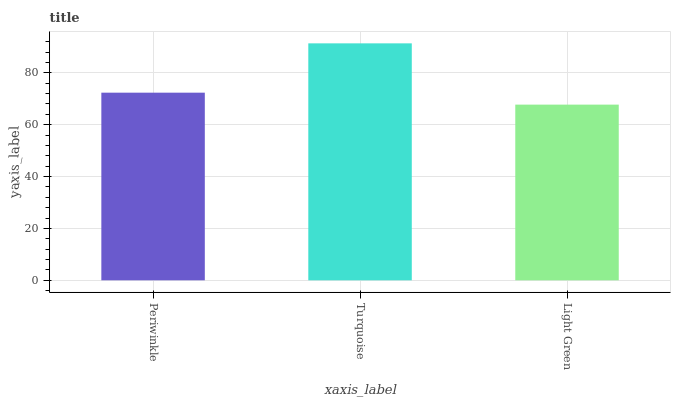Is Light Green the minimum?
Answer yes or no. Yes. Is Turquoise the maximum?
Answer yes or no. Yes. Is Turquoise the minimum?
Answer yes or no. No. Is Light Green the maximum?
Answer yes or no. No. Is Turquoise greater than Light Green?
Answer yes or no. Yes. Is Light Green less than Turquoise?
Answer yes or no. Yes. Is Light Green greater than Turquoise?
Answer yes or no. No. Is Turquoise less than Light Green?
Answer yes or no. No. Is Periwinkle the high median?
Answer yes or no. Yes. Is Periwinkle the low median?
Answer yes or no. Yes. Is Light Green the high median?
Answer yes or no. No. Is Turquoise the low median?
Answer yes or no. No. 